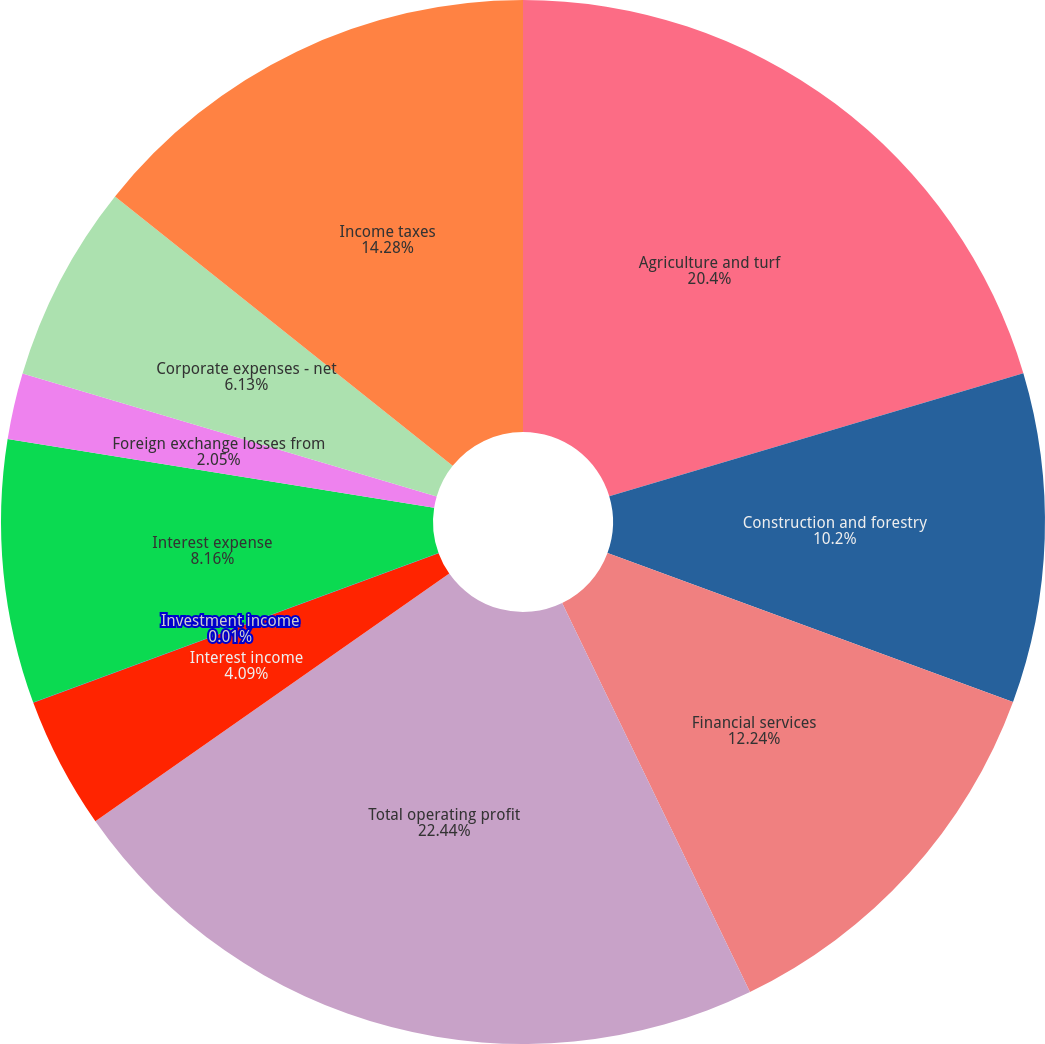<chart> <loc_0><loc_0><loc_500><loc_500><pie_chart><fcel>Agriculture and turf<fcel>Construction and forestry<fcel>Financial services<fcel>Total operating profit<fcel>Interest income<fcel>Investment income<fcel>Interest expense<fcel>Foreign exchange losses from<fcel>Corporate expenses - net<fcel>Income taxes<nl><fcel>20.4%<fcel>10.2%<fcel>12.24%<fcel>22.44%<fcel>4.09%<fcel>0.01%<fcel>8.16%<fcel>2.05%<fcel>6.13%<fcel>14.28%<nl></chart> 